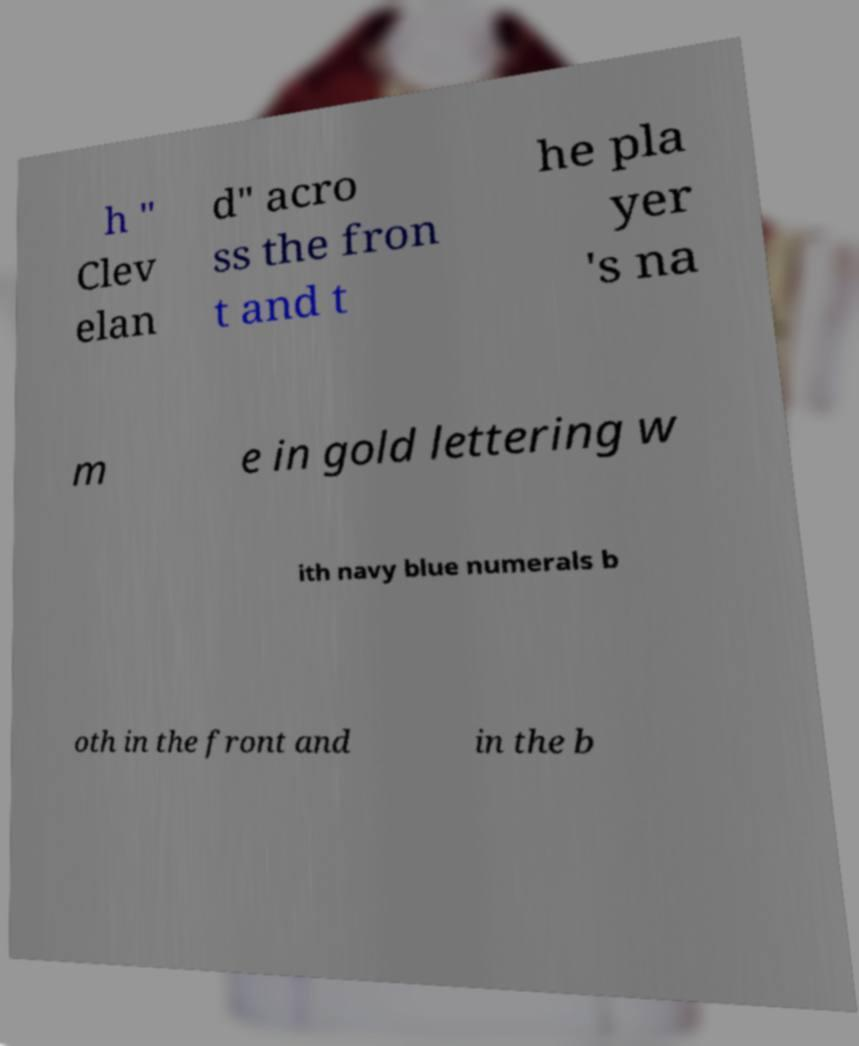Can you accurately transcribe the text from the provided image for me? h " Clev elan d" acro ss the fron t and t he pla yer 's na m e in gold lettering w ith navy blue numerals b oth in the front and in the b 